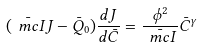<formula> <loc_0><loc_0><loc_500><loc_500>( \bar { \ m c { I } } J - \bar { Q } _ { 0 } ) \frac { d J } { d \bar { C } } = \frac { \phi ^ { 2 } } { \bar { \ m c { I } } } \bar { C } ^ { \gamma }</formula> 